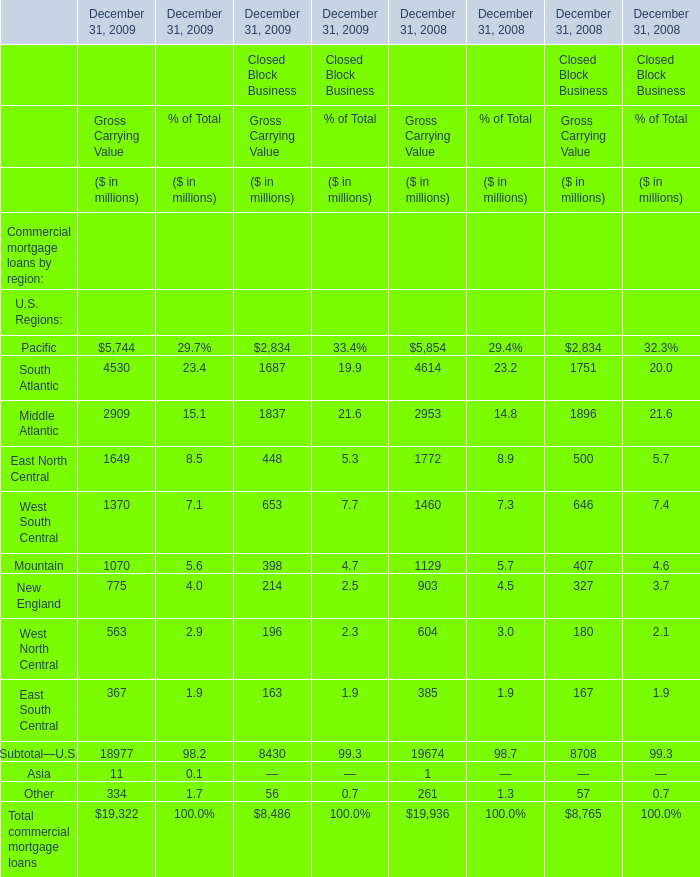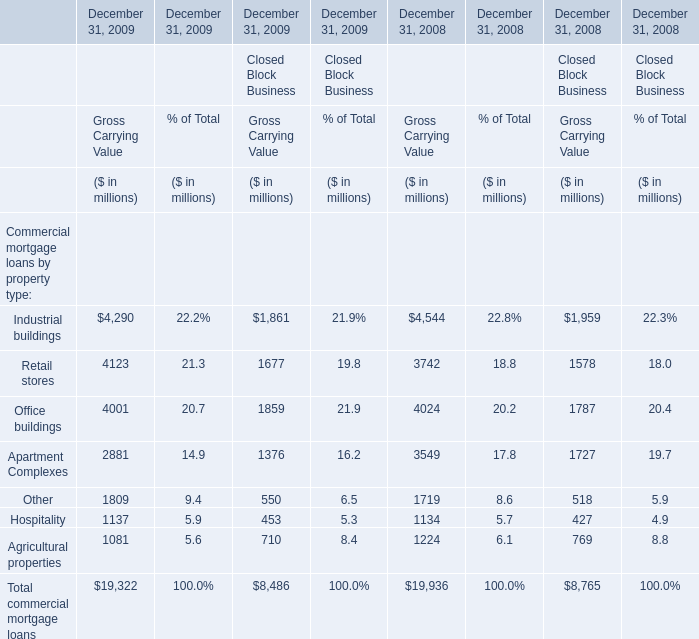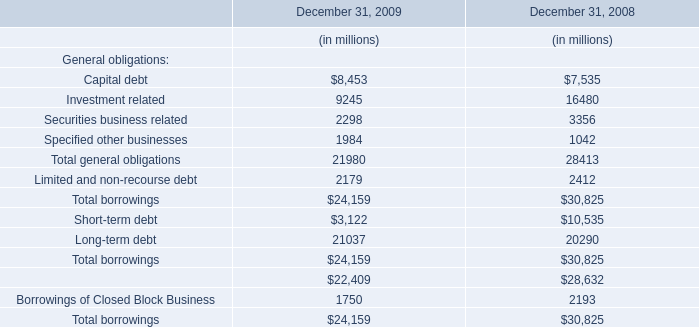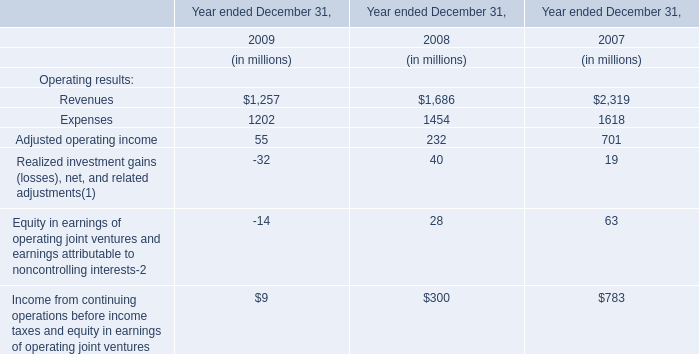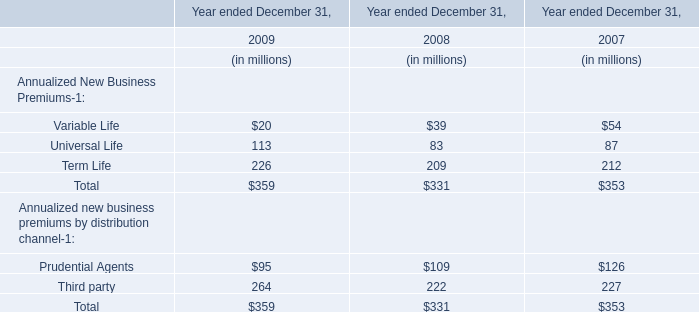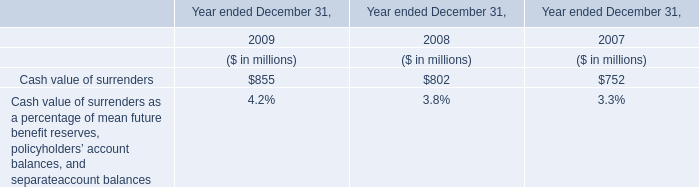Which year is Industrial buildings greater than 1 for Gross Carrying Value in Financial Services Businesses? 
Answer: December 31, 2009 December 31, 2008. 